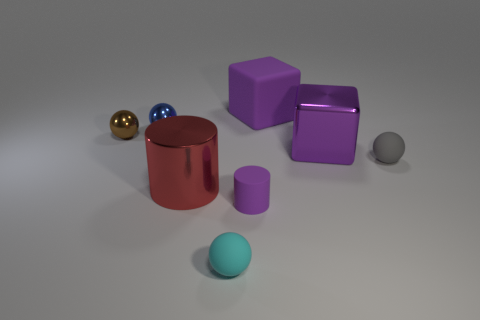Is there a green cube made of the same material as the tiny cylinder?
Ensure brevity in your answer.  No. There is a matte thing behind the brown metallic object; is it the same color as the metal block?
Provide a succinct answer. Yes. Are there the same number of large cylinders behind the tiny blue metallic thing and tiny purple things?
Offer a terse response. No. Are there any other metal blocks that have the same color as the large shiny cube?
Your answer should be very brief. No. Do the blue object and the cyan sphere have the same size?
Give a very brief answer. Yes. What size is the rubber object that is behind the large metallic object that is on the right side of the small cyan object?
Give a very brief answer. Large. There is a object that is both behind the tiny purple object and in front of the gray thing; how big is it?
Offer a terse response. Large. How many gray spheres are the same size as the brown sphere?
Offer a very short reply. 1. How many metallic objects are either small red objects or balls?
Offer a very short reply. 2. There is a matte cube that is the same color as the tiny matte cylinder; what size is it?
Provide a succinct answer. Large. 